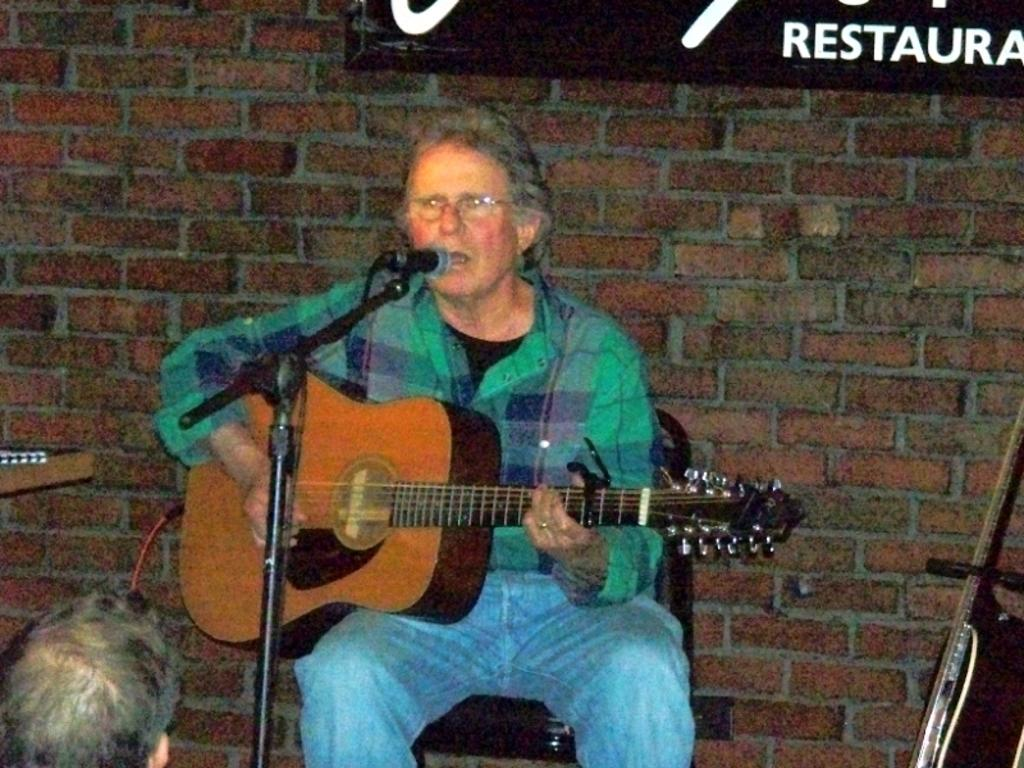What is the man in the image doing? The man is sitting on a chair, playing a guitar, and singing. What object is the man using to amplify his voice? There is a microphone in the image. What is behind the man in the image? There is a wall behind the man. What type of substance is the man using to enhance his singing performance in the image? There is no substance mentioned or visible in the image that the man is using to enhance his singing performance. 